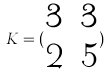<formula> <loc_0><loc_0><loc_500><loc_500>K = ( \begin{matrix} 3 & 3 \\ 2 & 5 \end{matrix} )</formula> 